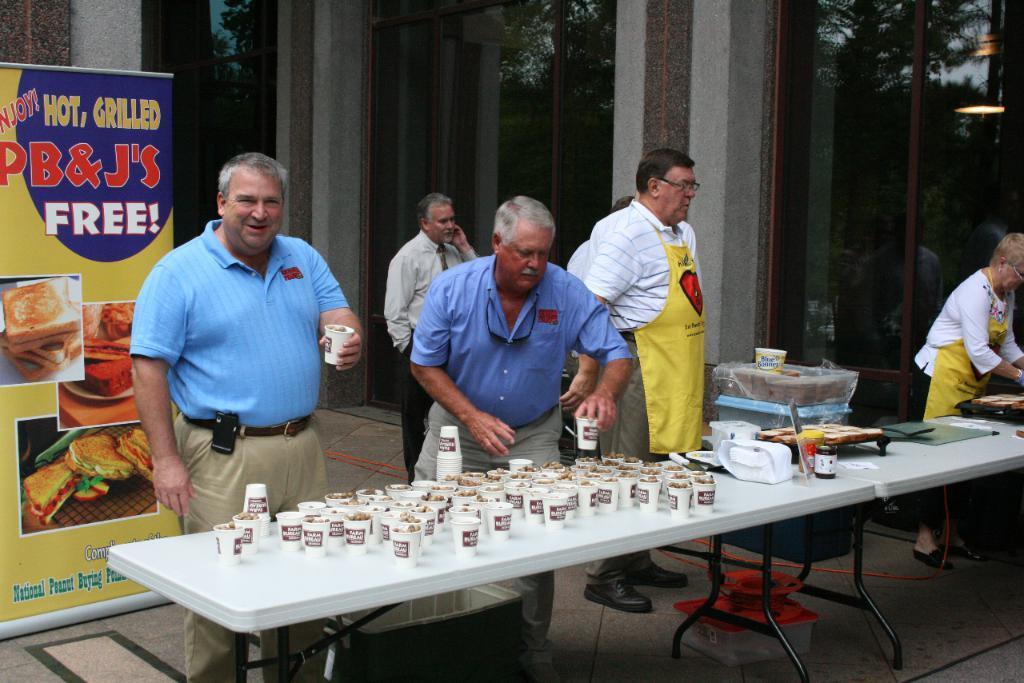Describe this image in one or two sentences. In this image, there are few people standing. And the image is clicked outside. There is a table, in the middle on which many glasses are kept. To the right, the woman is wearing yellow apron. To the left, there is a banner. In the background, there is a building with mirrors. 